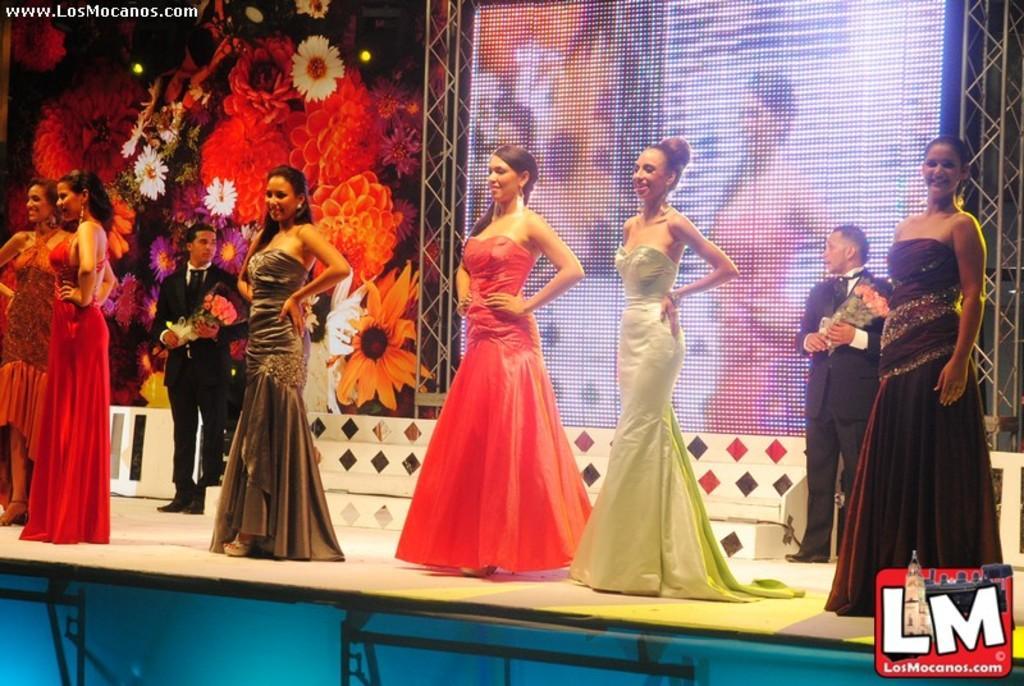In one or two sentences, can you explain what this image depicts? In this image there are persons standing on the stage. In the background there are flowers and there is a screen. 